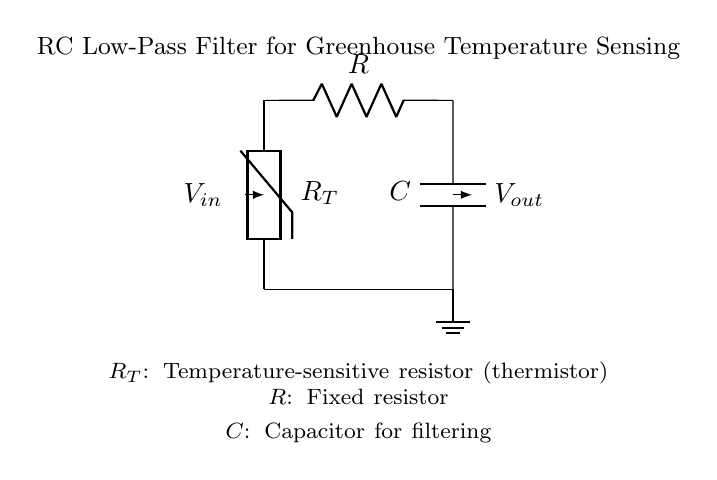What type of temperature sensor is used in the circuit? The diagram shows a thermistor labeled as R_T, which is a temperature-sensitive resistor used to measure temperature changes.
Answer: thermistor What components are in this RC low-pass filter? The circuit includes a thermistor, a resistor denoted as R, and a capacitor labeled as C. These are key components necessary for the filtering function of the circuit.
Answer: thermistor, resistor, capacitor What is the role of the capacitor in this circuit? The capacitor, indicated as C, is used for filtering. It smoothens the output signal by reducing the high-frequency noise in the temperature sensor output, allowing only the low-frequency signals through.
Answer: filtering What is the relationship between the resistor and the capacitor for filtering? The resistor (R) and capacitor (C) together determine the cutoff frequency of the filter. The time constant, calculated as the product of R and C, influences how quickly the circuit responds to changes in temperature.
Answer: time constant What is the direction of current flow in this circuit? The current flows from the temperature sensor through the resistor to the capacitor, ultimately leading to the output voltage (V_out). This flow can be traced from V_in to V_out in the diagram.
Answer: from V_in to V_out What can be inferred about the output voltage in relation to the input voltage? The output voltage (V_out) will be a smoothed version of the input voltage (V_in), depending on the temperature readings and the filtering effect of the capacitor. This implies V_out reacts more slowly to rapid changes in V_in.
Answer: V_out is a smoothed version of V_in 